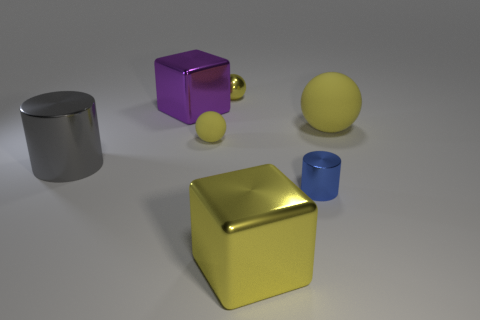Subtract all small yellow metallic spheres. How many spheres are left? 2 Add 2 large metallic objects. How many objects exist? 9 Subtract all yellow blocks. How many blocks are left? 1 Subtract all cylinders. How many objects are left? 5 Subtract 1 cylinders. How many cylinders are left? 1 Add 4 blue things. How many blue things exist? 5 Subtract 0 cyan cylinders. How many objects are left? 7 Subtract all cyan spheres. Subtract all red cubes. How many spheres are left? 3 Subtract all gray cubes. How many gray cylinders are left? 1 Subtract all large purple metallic cylinders. Subtract all tiny yellow things. How many objects are left? 5 